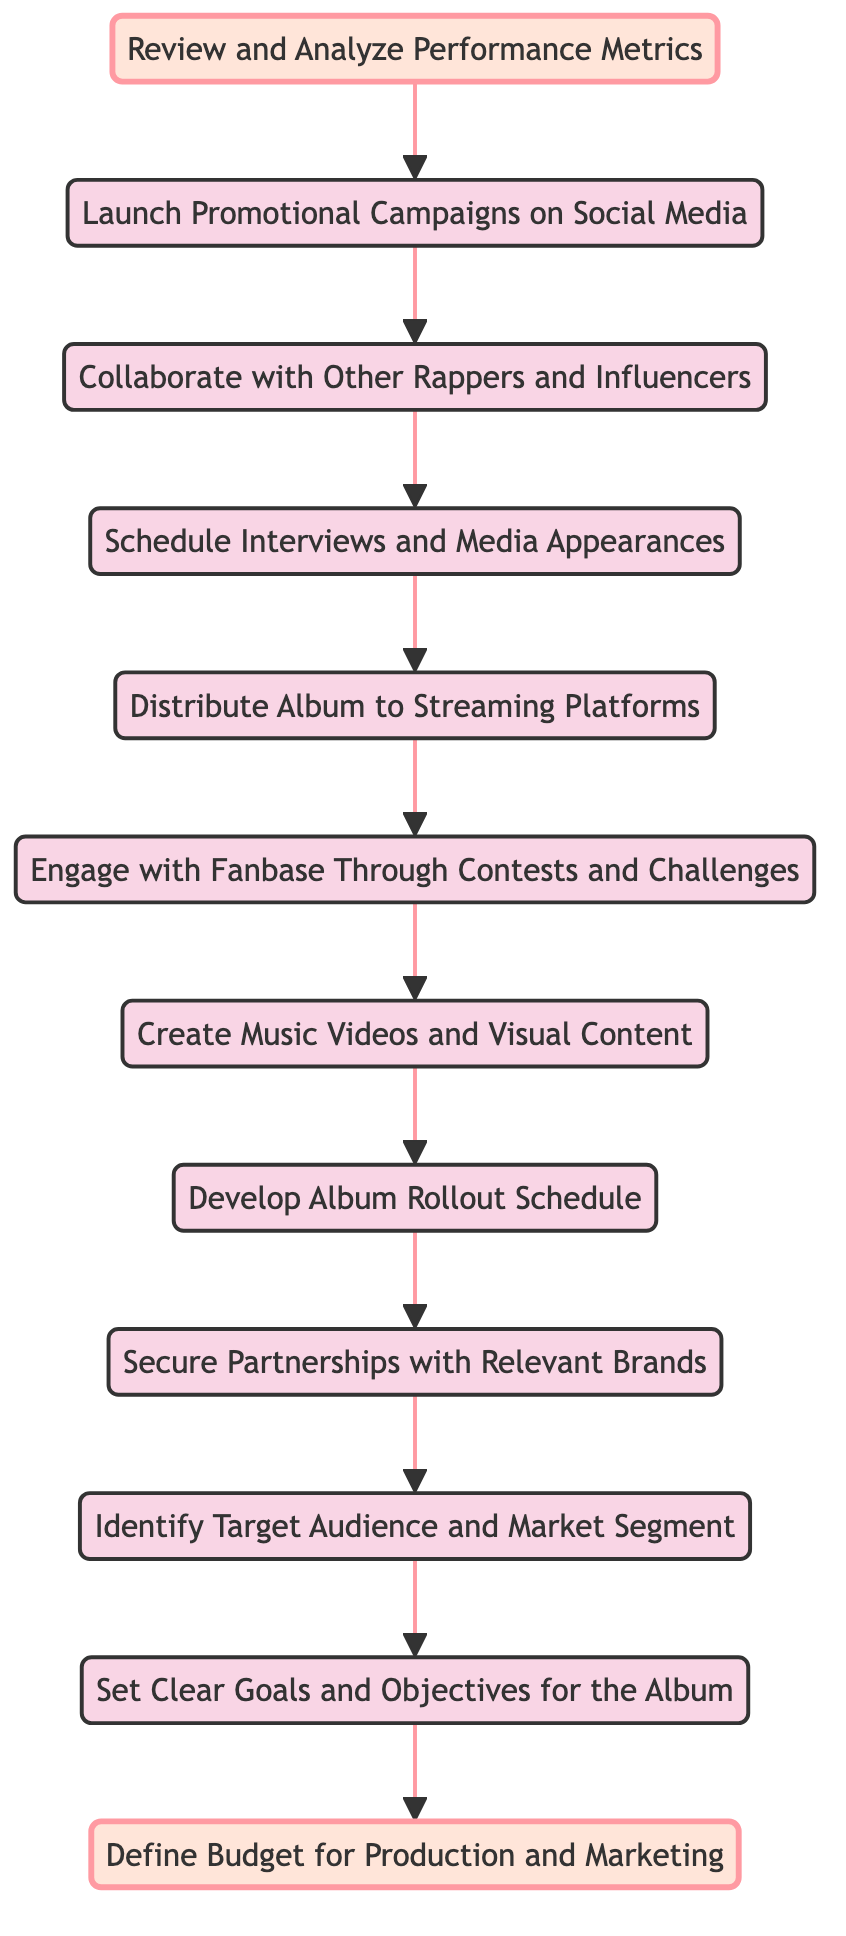What's the starting point of the flow in the diagram? The flowchart starts from "Review and Analyze Performance Metrics", which is the first node at the bottom of the diagram.
Answer: Review and Analyze Performance Metrics How many total nodes are there in the diagram? By counting all the distinct elements listed in the diagram, we find that there are a total of 12 nodes.
Answer: 12 What is the immediate next step after defining the budget? The next step after "Define Budget for Production and Marketing" is to "Set Clear Goals and Objectives for the Album", which flows directly above it in the diagram.
Answer: Set Clear Goals and Objectives for the Album Which node leads to the engagement with the fanbase? The node that leads to "Engage with Fanbase Through Contests and Challenges" is "Distribute Album to Streaming Platforms", showing the connection in the diagram flow.
Answer: Distribute Album to Streaming Platforms What is the final step of the flow in this diagram? The final step in the flow, which is at the top of the diagram, is "Define Budget for Production and Marketing", indicating the conclusion of the marketing plan creation.
Answer: Define Budget for Production and Marketing What is the relationship between "Collaborate with Other Rappers and Influencers" and "Schedule Interviews and Media Appearances"? "Collaborate with Other Rappers and Influencers" is the step that must be completed before moving to "Schedule Interviews and Media Appearances," indicating a direct connection in the flow of tasks.
Answer: Collaborate with Other Rappers and Influencers Which step must be taken right after creating visual content? After "Create Music Videos and Visual Content", the next step to be executed is "Develop Album Rollout Schedule", as seen in the upward flow of the diagram.
Answer: Develop Album Rollout Schedule What node precedes the identification of the target audience? The node that comes before "Identify Target Audience and Market Segment" is "Secure Partnerships with Relevant Brands", confirming the sequence of actions in the plan.
Answer: Secure Partnerships with Relevant Brands What is the link between performance metrics and promotional campaigns? The link is that "Launch Promotional Campaigns on Social Media" directly follows "Review and Analyze Performance Metrics", indicating that the analysis informs the launch of campaigns.
Answer: Launch Promotional Campaigns on Social Media 